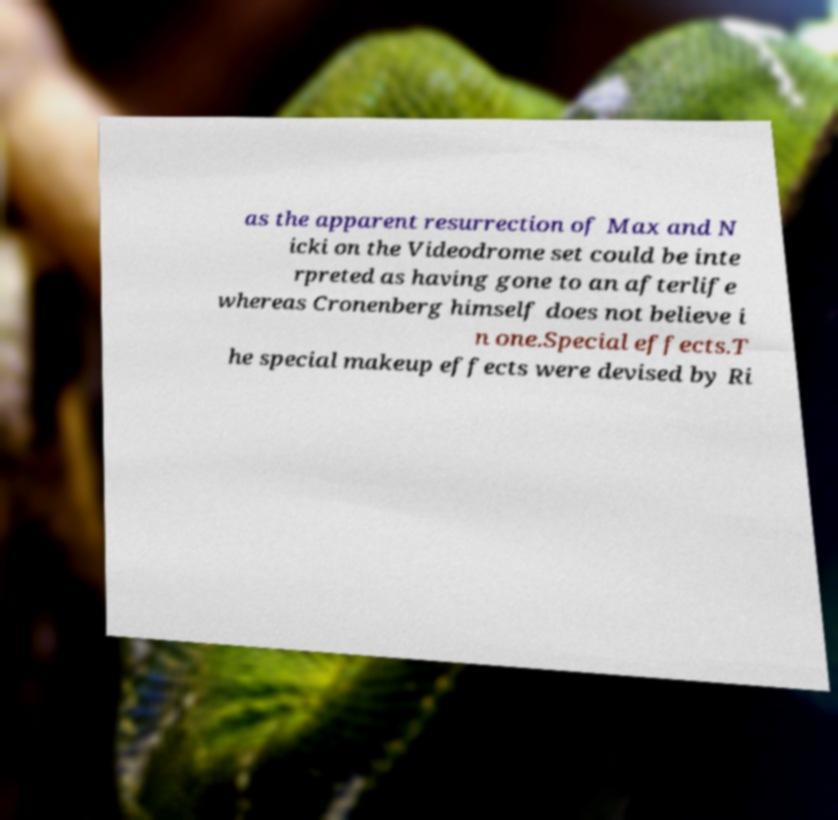Could you extract and type out the text from this image? as the apparent resurrection of Max and N icki on the Videodrome set could be inte rpreted as having gone to an afterlife whereas Cronenberg himself does not believe i n one.Special effects.T he special makeup effects were devised by Ri 